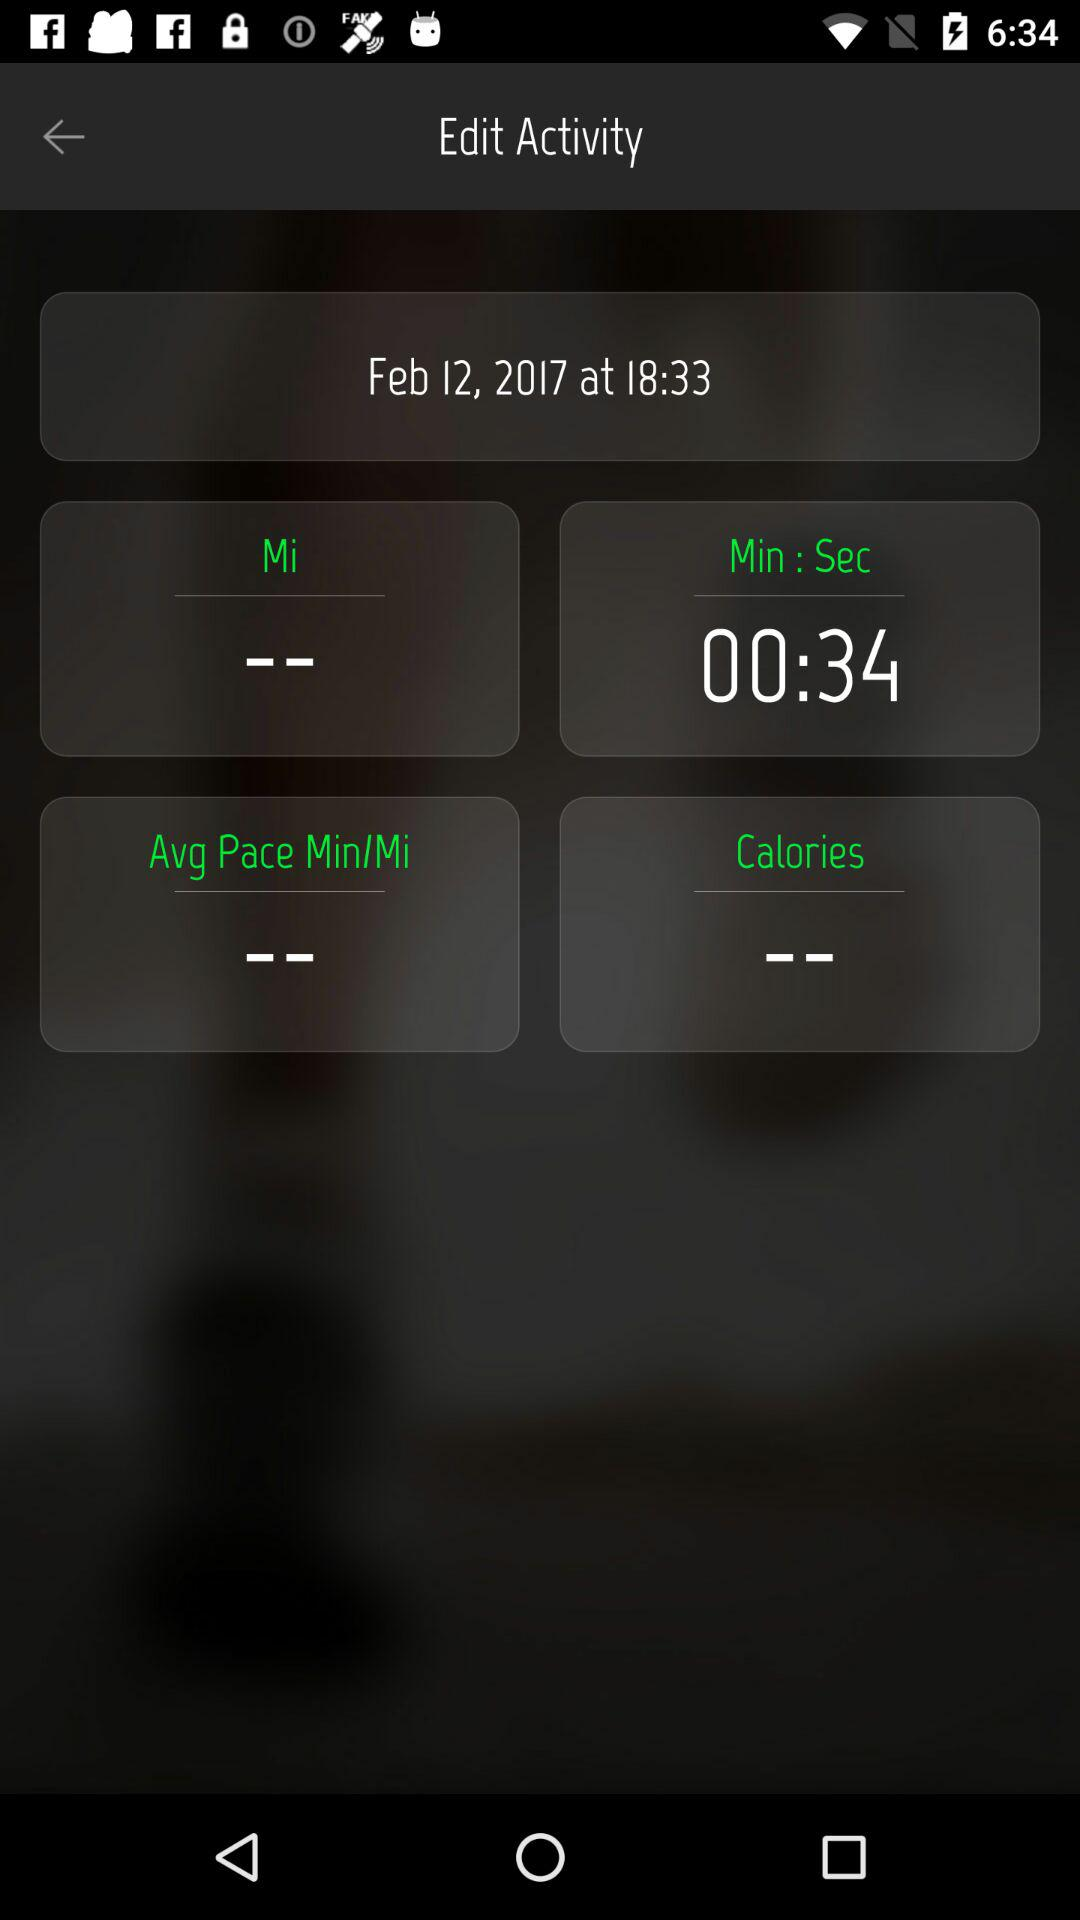How many seconds are mentioned for running? The mentioned seconds for running are 34. 